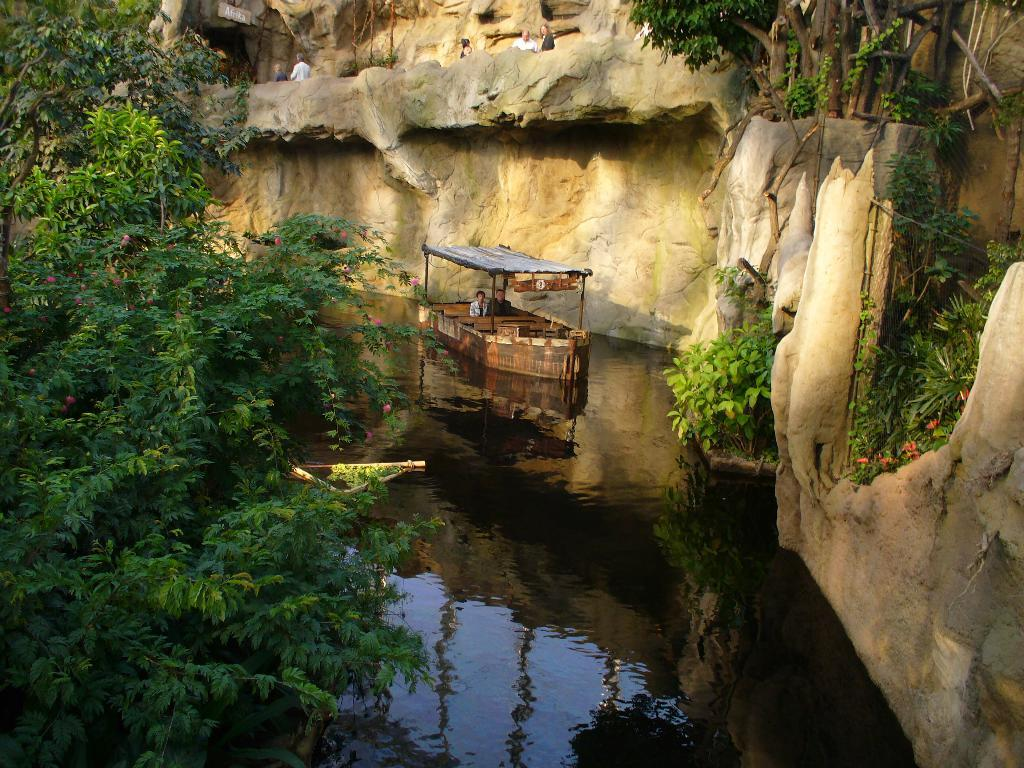What is the person in the image doing? The person is in a boat. How is the boat positioned in relation to the water? The boat is above the water. What can be seen in the background of the image? Trees, people, and a wall are visible in the background of the image. What type of blood is visible on the person's hands in the image? There is no blood visible on the person's hands in the image. What kind of game are the people in the background playing in the image? There is no indication of a game being played in the image; the people in the background are simply visible. 